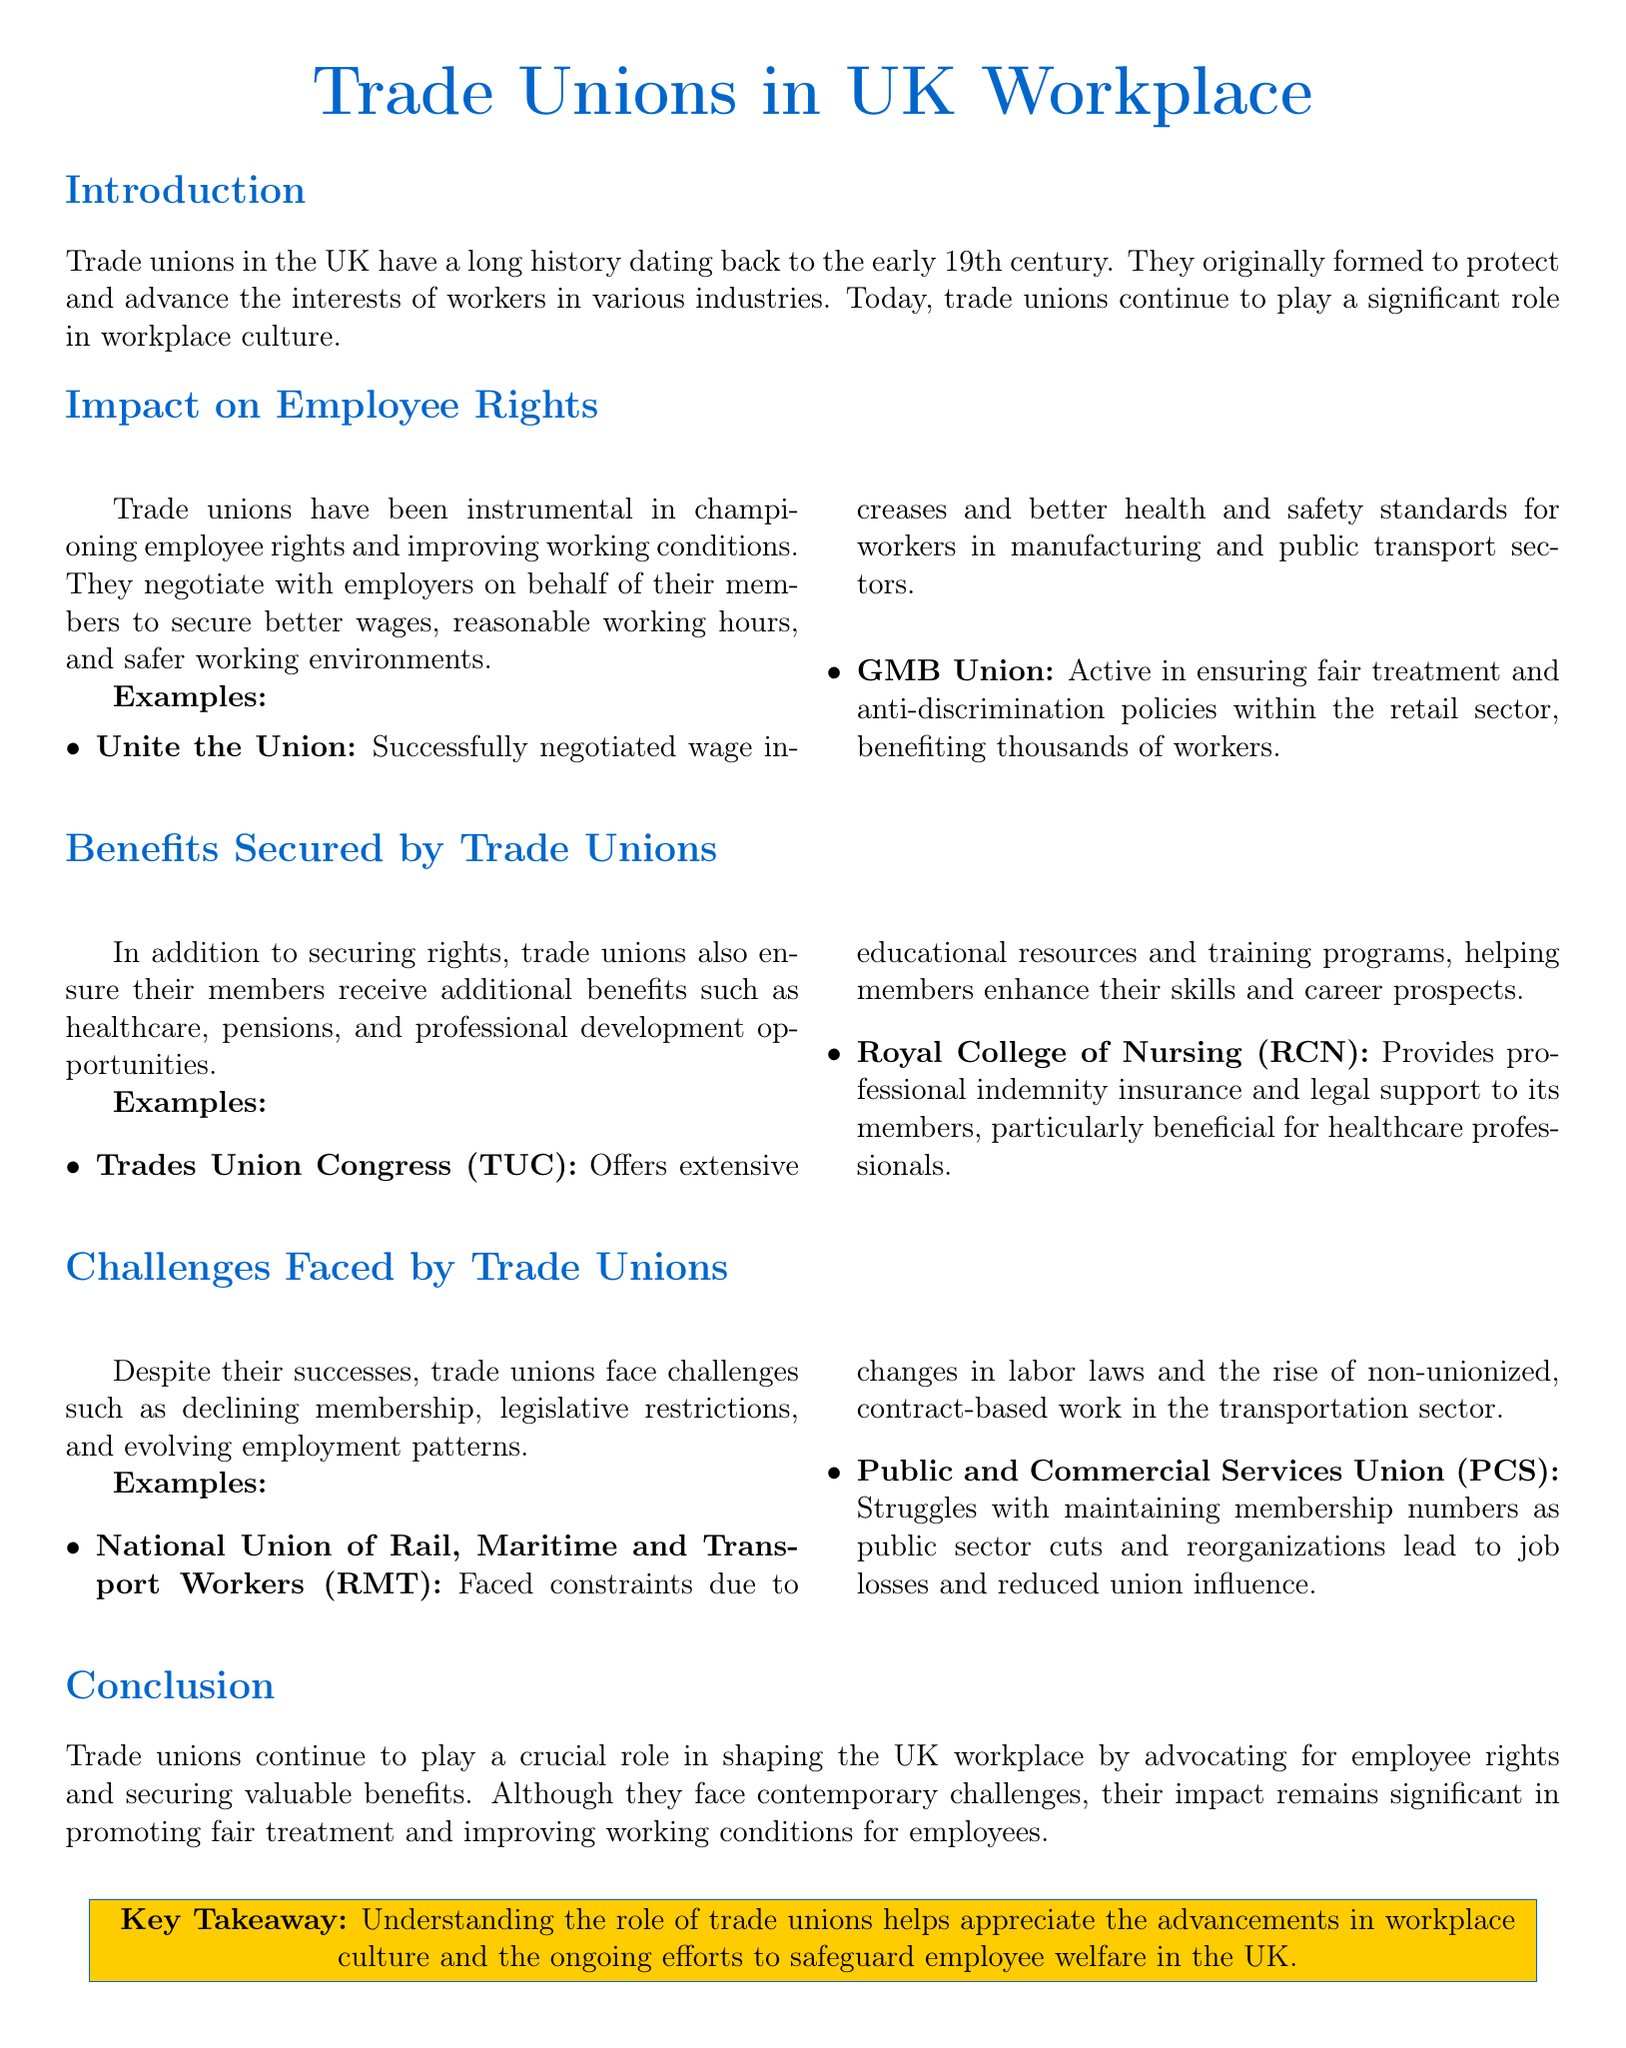What year did trade unions in the UK start forming? The document states that trade unions have a long history dating back to the early 19th century.
Answer: early 19th century Which union successfully negotiated better health and safety standards? It mentions that Unite the Union successfully negotiated wage increases and better health and safety standards.
Answer: Unite the Union What specific benefit does the Royal College of Nursing provide? The document outlines that the Royal College of Nursing provides professional indemnity insurance and legal support to its members.
Answer: professional indemnity insurance and legal support What challenge is mentioned regarding the National Union of Rail's operations? The document states that the National Union of Rail, Maritime and Transport Workers faced constraints due to changes in labor laws.
Answer: changes in labor laws What is the key takeaway regarding trade unions? The document summarizes the key takeaway as understanding the role of trade unions helps appreciate advancements in workplace culture.
Answer: understanding the role of trade unions 